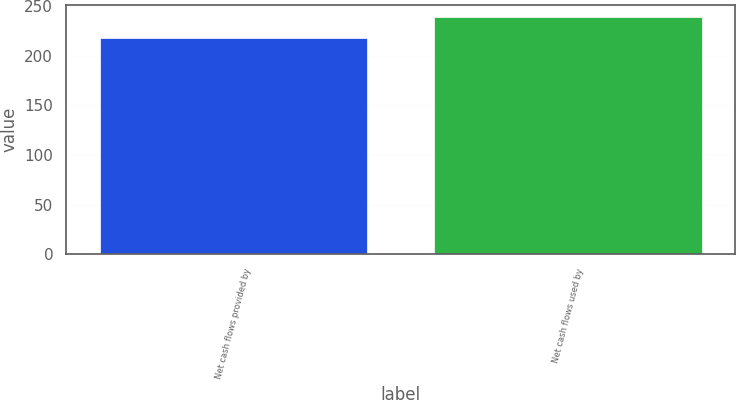Convert chart. <chart><loc_0><loc_0><loc_500><loc_500><bar_chart><fcel>Net cash flows provided by<fcel>Net cash flows used by<nl><fcel>218.2<fcel>239<nl></chart> 